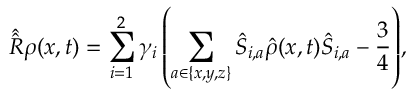Convert formula to latex. <formula><loc_0><loc_0><loc_500><loc_500>\hat { \hat { R } } \rho ( x , t ) = \sum _ { i = 1 } ^ { 2 } { { \gamma _ { i } } \left ( { \sum _ { a \in \{ x , y , z \} } { { { \hat { S } } _ { i , a } } \hat { \rho } ( x , t ) { { \hat { S } } _ { i , a } } - \frac { 3 } { 4 } } } \right ) } ,</formula> 